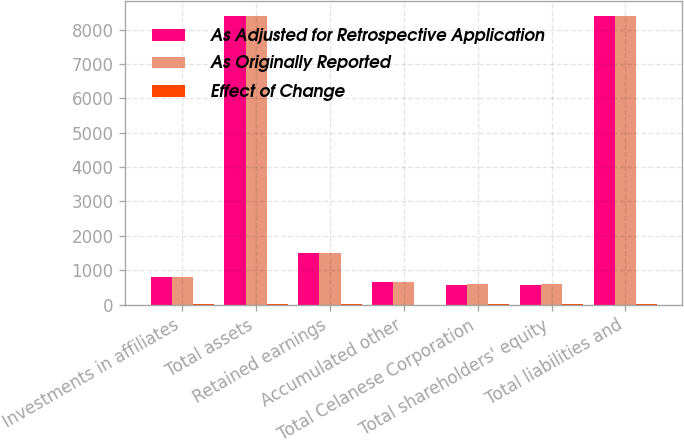<chart> <loc_0><loc_0><loc_500><loc_500><stacked_bar_chart><ecel><fcel>Investments in affiliates<fcel>Total assets<fcel>Retained earnings<fcel>Accumulated other<fcel>Total Celanese Corporation<fcel>Total shareholders' equity<fcel>Total liabilities and<nl><fcel>As Adjusted for Retrospective Application<fcel>790<fcel>8410<fcel>1502<fcel>659<fcel>584<fcel>584<fcel>8410<nl><fcel>As Originally Reported<fcel>792<fcel>8412<fcel>1505<fcel>660<fcel>586<fcel>586<fcel>8412<nl><fcel>Effect of Change<fcel>2<fcel>2<fcel>3<fcel>1<fcel>2<fcel>2<fcel>2<nl></chart> 